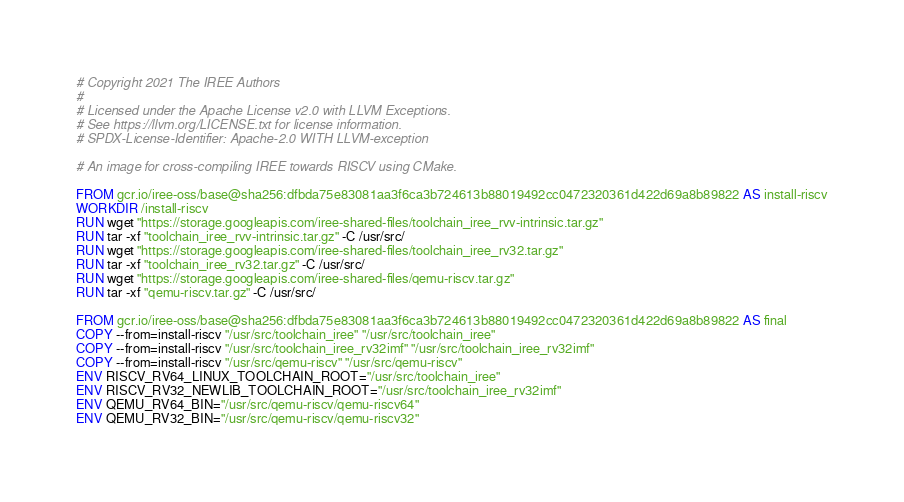Convert code to text. <code><loc_0><loc_0><loc_500><loc_500><_Dockerfile_># Copyright 2021 The IREE Authors
#
# Licensed under the Apache License v2.0 with LLVM Exceptions.
# See https://llvm.org/LICENSE.txt for license information.
# SPDX-License-Identifier: Apache-2.0 WITH LLVM-exception

# An image for cross-compiling IREE towards RISCV using CMake.

FROM gcr.io/iree-oss/base@sha256:dfbda75e83081aa3f6ca3b724613b88019492cc0472320361d422d69a8b89822 AS install-riscv
WORKDIR /install-riscv
RUN wget "https://storage.googleapis.com/iree-shared-files/toolchain_iree_rvv-intrinsic.tar.gz"
RUN tar -xf "toolchain_iree_rvv-intrinsic.tar.gz" -C /usr/src/
RUN wget "https://storage.googleapis.com/iree-shared-files/toolchain_iree_rv32.tar.gz"
RUN tar -xf "toolchain_iree_rv32.tar.gz" -C /usr/src/
RUN wget "https://storage.googleapis.com/iree-shared-files/qemu-riscv.tar.gz"
RUN tar -xf "qemu-riscv.tar.gz" -C /usr/src/

FROM gcr.io/iree-oss/base@sha256:dfbda75e83081aa3f6ca3b724613b88019492cc0472320361d422d69a8b89822 AS final
COPY --from=install-riscv "/usr/src/toolchain_iree" "/usr/src/toolchain_iree"
COPY --from=install-riscv "/usr/src/toolchain_iree_rv32imf" "/usr/src/toolchain_iree_rv32imf"
COPY --from=install-riscv "/usr/src/qemu-riscv" "/usr/src/qemu-riscv"
ENV RISCV_RV64_LINUX_TOOLCHAIN_ROOT="/usr/src/toolchain_iree"
ENV RISCV_RV32_NEWLIB_TOOLCHAIN_ROOT="/usr/src/toolchain_iree_rv32imf"
ENV QEMU_RV64_BIN="/usr/src/qemu-riscv/qemu-riscv64"
ENV QEMU_RV32_BIN="/usr/src/qemu-riscv/qemu-riscv32"
</code> 